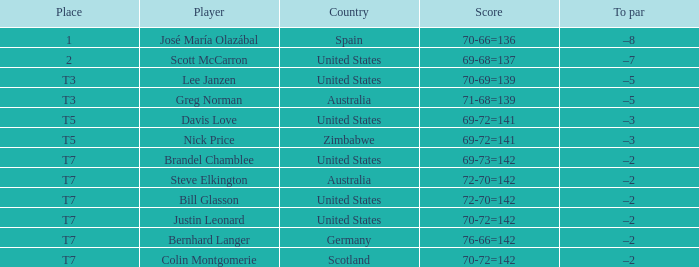Name the Player who has a To par of –2 and a Score of 69-73=142? Brandel Chamblee. Help me parse the entirety of this table. {'header': ['Place', 'Player', 'Country', 'Score', 'To par'], 'rows': [['1', 'José María Olazábal', 'Spain', '70-66=136', '–8'], ['2', 'Scott McCarron', 'United States', '69-68=137', '–7'], ['T3', 'Lee Janzen', 'United States', '70-69=139', '–5'], ['T3', 'Greg Norman', 'Australia', '71-68=139', '–5'], ['T5', 'Davis Love', 'United States', '69-72=141', '–3'], ['T5', 'Nick Price', 'Zimbabwe', '69-72=141', '–3'], ['T7', 'Brandel Chamblee', 'United States', '69-73=142', '–2'], ['T7', 'Steve Elkington', 'Australia', '72-70=142', '–2'], ['T7', 'Bill Glasson', 'United States', '72-70=142', '–2'], ['T7', 'Justin Leonard', 'United States', '70-72=142', '–2'], ['T7', 'Bernhard Langer', 'Germany', '76-66=142', '–2'], ['T7', 'Colin Montgomerie', 'Scotland', '70-72=142', '–2']]} 